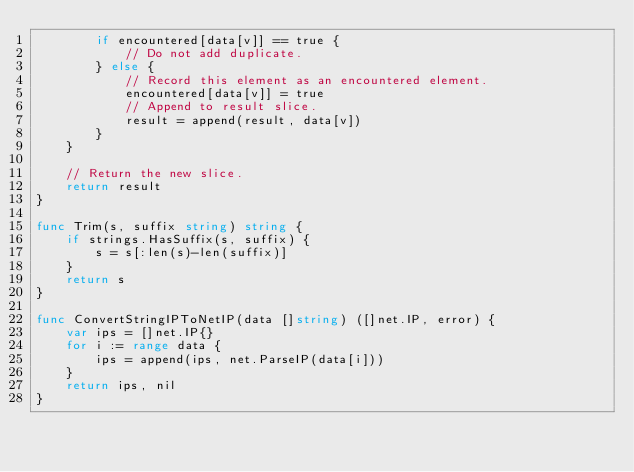Convert code to text. <code><loc_0><loc_0><loc_500><loc_500><_Go_>		if encountered[data[v]] == true {
			// Do not add duplicate.
		} else {
			// Record this element as an encountered element.
			encountered[data[v]] = true
			// Append to result slice.
			result = append(result, data[v])
		}
	}

	// Return the new slice.
	return result
}

func Trim(s, suffix string) string {
	if strings.HasSuffix(s, suffix) {
		s = s[:len(s)-len(suffix)]
	}
	return s
}

func ConvertStringIPToNetIP(data []string) ([]net.IP, error) {
	var ips = []net.IP{}
	for i := range data {
		ips = append(ips, net.ParseIP(data[i]))
	}
	return ips, nil
}
</code> 